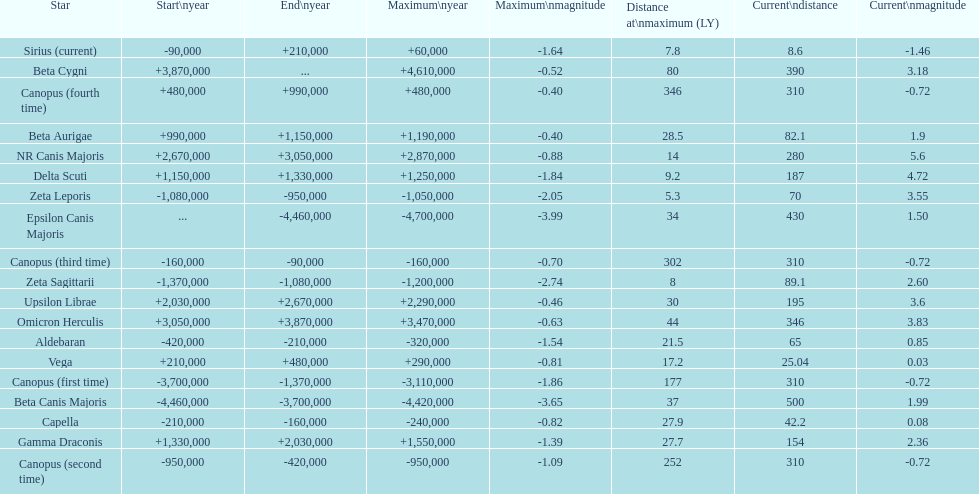How many stars have a magnitude greater than zero? 14. 